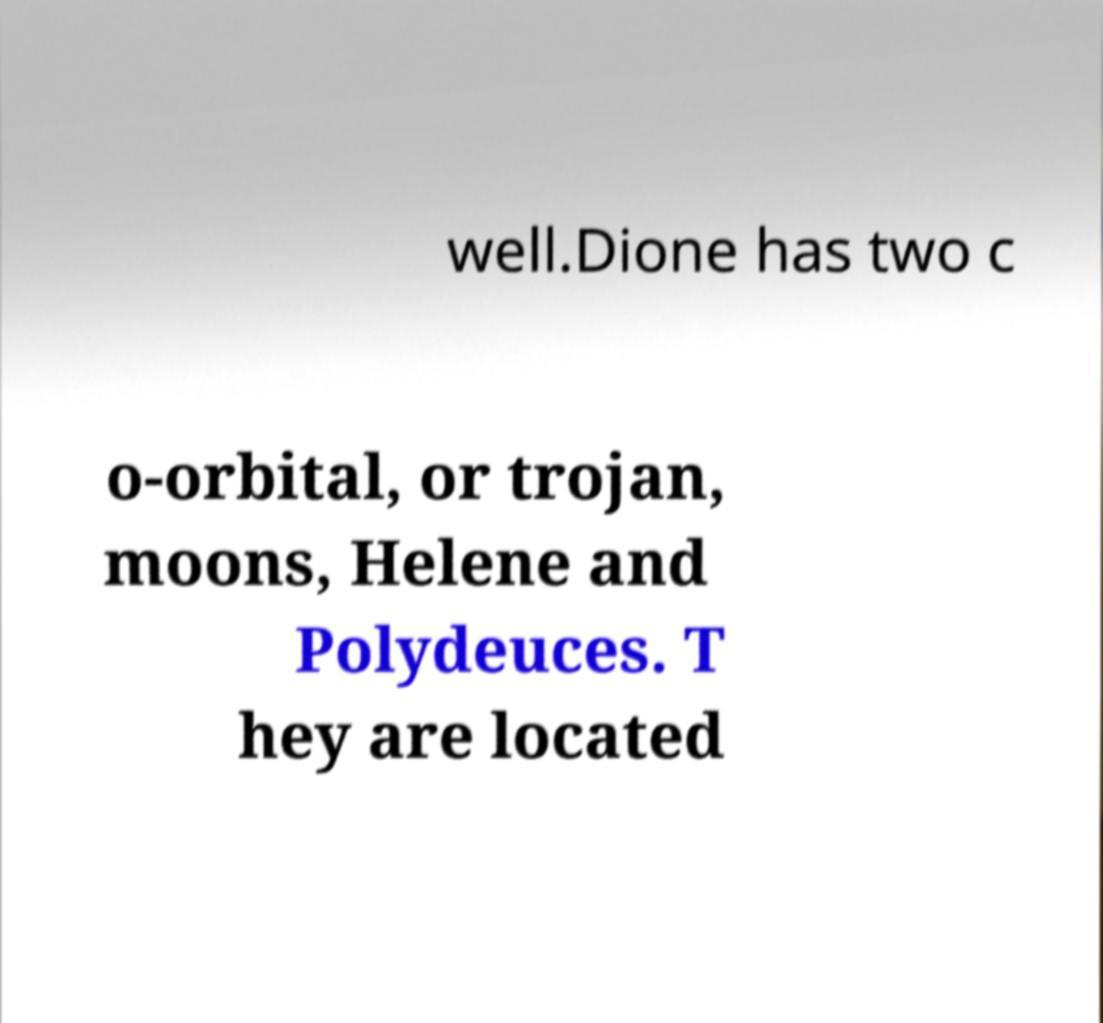Can you read and provide the text displayed in the image?This photo seems to have some interesting text. Can you extract and type it out for me? well.Dione has two c o-orbital, or trojan, moons, Helene and Polydeuces. T hey are located 